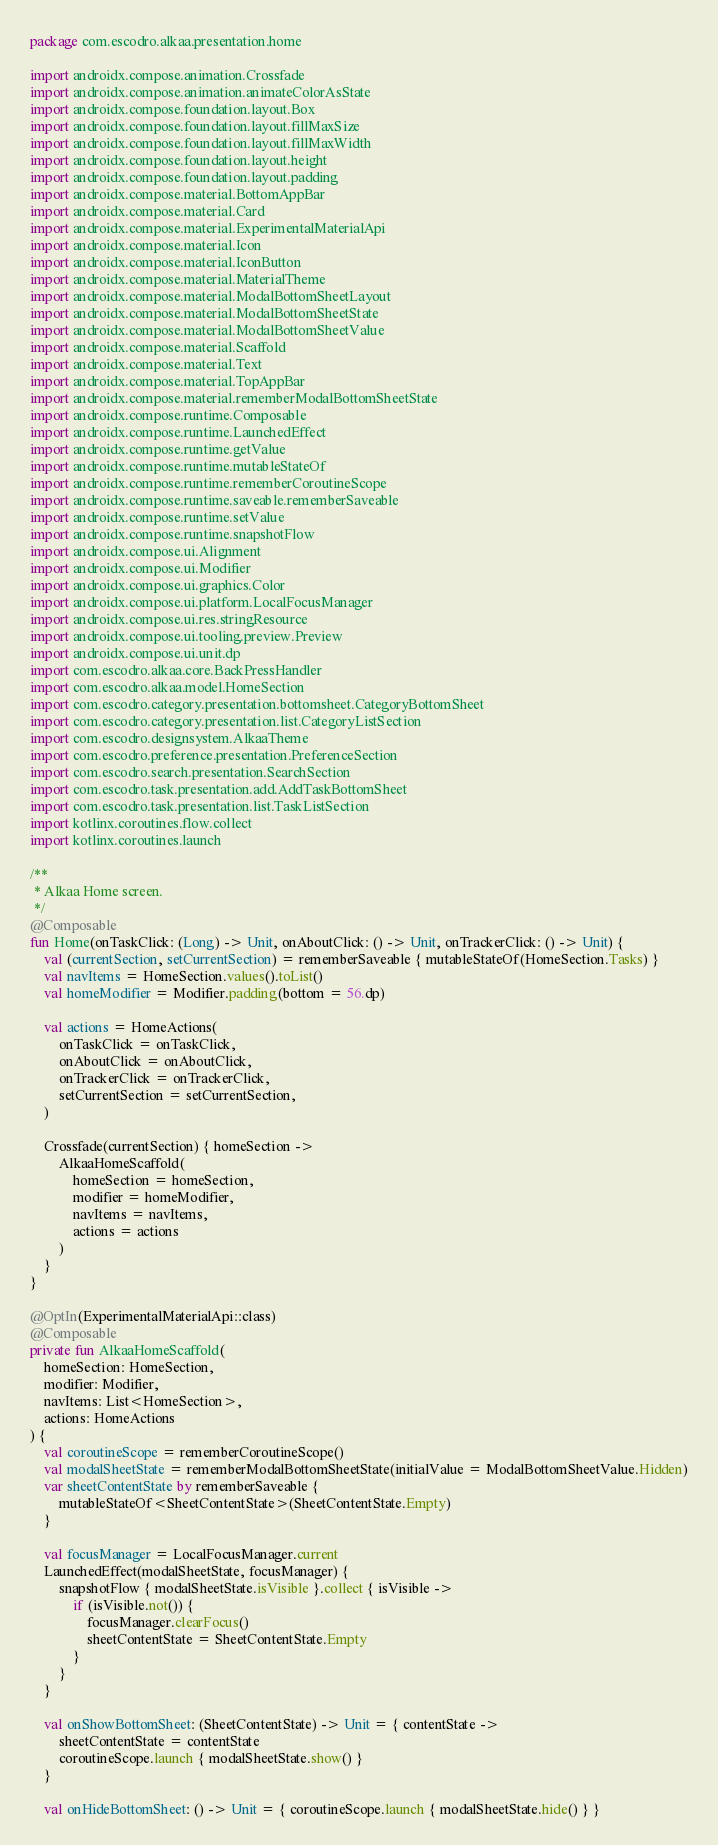<code> <loc_0><loc_0><loc_500><loc_500><_Kotlin_>package com.escodro.alkaa.presentation.home

import androidx.compose.animation.Crossfade
import androidx.compose.animation.animateColorAsState
import androidx.compose.foundation.layout.Box
import androidx.compose.foundation.layout.fillMaxSize
import androidx.compose.foundation.layout.fillMaxWidth
import androidx.compose.foundation.layout.height
import androidx.compose.foundation.layout.padding
import androidx.compose.material.BottomAppBar
import androidx.compose.material.Card
import androidx.compose.material.ExperimentalMaterialApi
import androidx.compose.material.Icon
import androidx.compose.material.IconButton
import androidx.compose.material.MaterialTheme
import androidx.compose.material.ModalBottomSheetLayout
import androidx.compose.material.ModalBottomSheetState
import androidx.compose.material.ModalBottomSheetValue
import androidx.compose.material.Scaffold
import androidx.compose.material.Text
import androidx.compose.material.TopAppBar
import androidx.compose.material.rememberModalBottomSheetState
import androidx.compose.runtime.Composable
import androidx.compose.runtime.LaunchedEffect
import androidx.compose.runtime.getValue
import androidx.compose.runtime.mutableStateOf
import androidx.compose.runtime.rememberCoroutineScope
import androidx.compose.runtime.saveable.rememberSaveable
import androidx.compose.runtime.setValue
import androidx.compose.runtime.snapshotFlow
import androidx.compose.ui.Alignment
import androidx.compose.ui.Modifier
import androidx.compose.ui.graphics.Color
import androidx.compose.ui.platform.LocalFocusManager
import androidx.compose.ui.res.stringResource
import androidx.compose.ui.tooling.preview.Preview
import androidx.compose.ui.unit.dp
import com.escodro.alkaa.core.BackPressHandler
import com.escodro.alkaa.model.HomeSection
import com.escodro.category.presentation.bottomsheet.CategoryBottomSheet
import com.escodro.category.presentation.list.CategoryListSection
import com.escodro.designsystem.AlkaaTheme
import com.escodro.preference.presentation.PreferenceSection
import com.escodro.search.presentation.SearchSection
import com.escodro.task.presentation.add.AddTaskBottomSheet
import com.escodro.task.presentation.list.TaskListSection
import kotlinx.coroutines.flow.collect
import kotlinx.coroutines.launch

/**
 * Alkaa Home screen.
 */
@Composable
fun Home(onTaskClick: (Long) -> Unit, onAboutClick: () -> Unit, onTrackerClick: () -> Unit) {
    val (currentSection, setCurrentSection) = rememberSaveable { mutableStateOf(HomeSection.Tasks) }
    val navItems = HomeSection.values().toList()
    val homeModifier = Modifier.padding(bottom = 56.dp)

    val actions = HomeActions(
        onTaskClick = onTaskClick,
        onAboutClick = onAboutClick,
        onTrackerClick = onTrackerClick,
        setCurrentSection = setCurrentSection,
    )

    Crossfade(currentSection) { homeSection ->
        AlkaaHomeScaffold(
            homeSection = homeSection,
            modifier = homeModifier,
            navItems = navItems,
            actions = actions
        )
    }
}

@OptIn(ExperimentalMaterialApi::class)
@Composable
private fun AlkaaHomeScaffold(
    homeSection: HomeSection,
    modifier: Modifier,
    navItems: List<HomeSection>,
    actions: HomeActions
) {
    val coroutineScope = rememberCoroutineScope()
    val modalSheetState = rememberModalBottomSheetState(initialValue = ModalBottomSheetValue.Hidden)
    var sheetContentState by rememberSaveable {
        mutableStateOf<SheetContentState>(SheetContentState.Empty)
    }

    val focusManager = LocalFocusManager.current
    LaunchedEffect(modalSheetState, focusManager) {
        snapshotFlow { modalSheetState.isVisible }.collect { isVisible ->
            if (isVisible.not()) {
                focusManager.clearFocus()
                sheetContentState = SheetContentState.Empty
            }
        }
    }

    val onShowBottomSheet: (SheetContentState) -> Unit = { contentState ->
        sheetContentState = contentState
        coroutineScope.launch { modalSheetState.show() }
    }

    val onHideBottomSheet: () -> Unit = { coroutineScope.launch { modalSheetState.hide() } }
</code> 